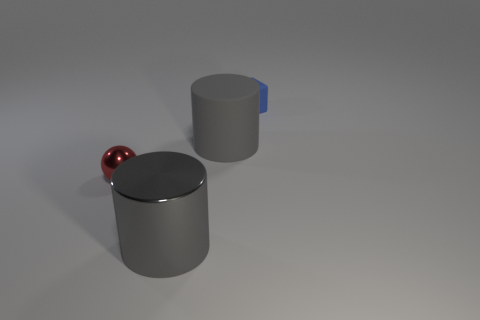There is a rubber thing that is in front of the blue rubber cube; what size is it?
Offer a very short reply. Large. Is the shiny cylinder the same color as the large rubber cylinder?
Provide a short and direct response. Yes. How many tiny objects are either yellow objects or shiny balls?
Your answer should be very brief. 1. Is there anything else that is the same color as the large matte thing?
Your answer should be very brief. Yes. Are there any tiny things in front of the tiny blue rubber object?
Make the answer very short. Yes. What is the size of the shiny object that is behind the gray thing in front of the gray rubber cylinder?
Your response must be concise. Small. Are there the same number of blue rubber blocks that are to the left of the red sphere and large matte things that are in front of the small blue thing?
Your answer should be very brief. No. There is a matte thing to the left of the small cube; are there any red metal objects right of it?
Keep it short and to the point. No. There is a gray object behind the small object in front of the small blue cube; what number of red metallic things are on the left side of it?
Ensure brevity in your answer.  1. Is the number of red metal objects less than the number of tiny green metal balls?
Your answer should be very brief. No. 